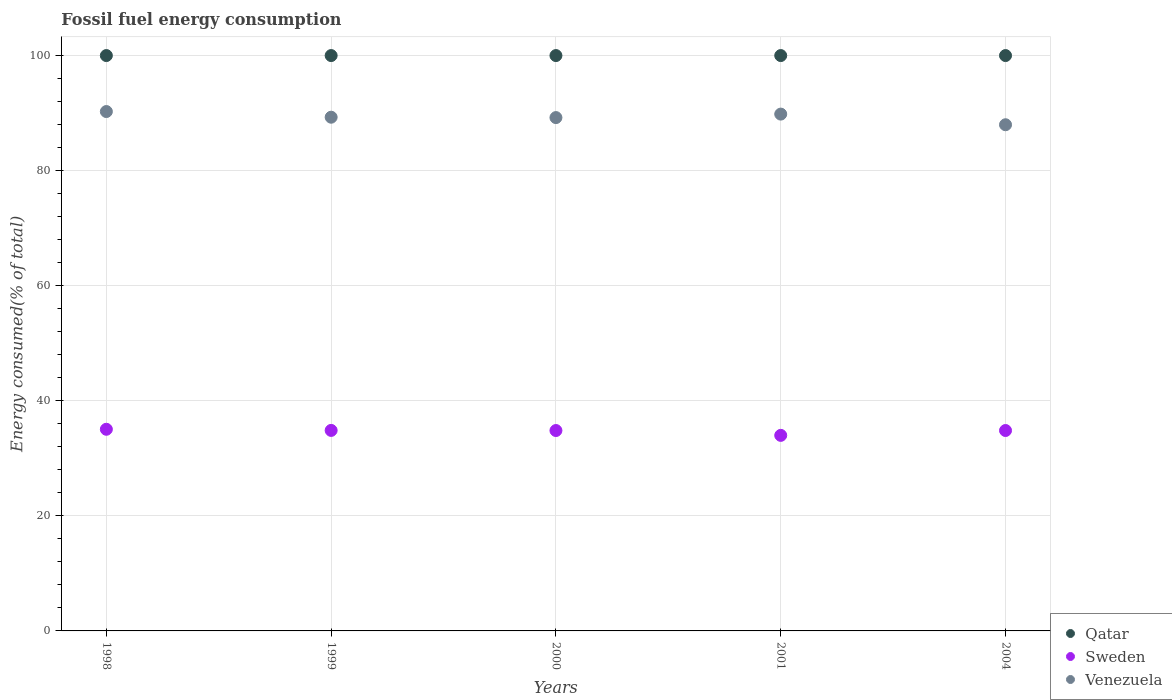How many different coloured dotlines are there?
Keep it short and to the point. 3. What is the percentage of energy consumed in Sweden in 2004?
Your answer should be compact. 34.83. Across all years, what is the maximum percentage of energy consumed in Sweden?
Give a very brief answer. 35.05. Across all years, what is the minimum percentage of energy consumed in Venezuela?
Ensure brevity in your answer.  87.98. In which year was the percentage of energy consumed in Qatar minimum?
Offer a terse response. 2000. What is the total percentage of energy consumed in Venezuela in the graph?
Your answer should be compact. 446.58. What is the difference between the percentage of energy consumed in Sweden in 1999 and that in 2000?
Your answer should be very brief. 0.02. What is the difference between the percentage of energy consumed in Sweden in 1998 and the percentage of energy consumed in Venezuela in 1999?
Your answer should be very brief. -54.24. What is the average percentage of energy consumed in Sweden per year?
Ensure brevity in your answer.  34.71. In the year 2004, what is the difference between the percentage of energy consumed in Qatar and percentage of energy consumed in Venezuela?
Offer a terse response. 12.02. What is the ratio of the percentage of energy consumed in Sweden in 2001 to that in 2004?
Offer a terse response. 0.98. Is the percentage of energy consumed in Qatar in 1998 less than that in 1999?
Give a very brief answer. No. What is the difference between the highest and the lowest percentage of energy consumed in Qatar?
Make the answer very short. 9.157250900670988e-6. In how many years, is the percentage of energy consumed in Venezuela greater than the average percentage of energy consumed in Venezuela taken over all years?
Keep it short and to the point. 2. Is the sum of the percentage of energy consumed in Qatar in 1998 and 2000 greater than the maximum percentage of energy consumed in Sweden across all years?
Give a very brief answer. Yes. How many dotlines are there?
Provide a succinct answer. 3. How many years are there in the graph?
Provide a short and direct response. 5. Are the values on the major ticks of Y-axis written in scientific E-notation?
Offer a very short reply. No. Where does the legend appear in the graph?
Your answer should be compact. Bottom right. How many legend labels are there?
Offer a terse response. 3. How are the legend labels stacked?
Provide a succinct answer. Vertical. What is the title of the graph?
Give a very brief answer. Fossil fuel energy consumption. What is the label or title of the Y-axis?
Your answer should be compact. Energy consumed(% of total). What is the Energy consumed(% of total) of Sweden in 1998?
Your answer should be compact. 35.05. What is the Energy consumed(% of total) of Venezuela in 1998?
Give a very brief answer. 90.27. What is the Energy consumed(% of total) in Qatar in 1999?
Your answer should be compact. 100. What is the Energy consumed(% of total) of Sweden in 1999?
Offer a terse response. 34.85. What is the Energy consumed(% of total) in Venezuela in 1999?
Your answer should be compact. 89.29. What is the Energy consumed(% of total) of Qatar in 2000?
Offer a terse response. 100. What is the Energy consumed(% of total) in Sweden in 2000?
Offer a very short reply. 34.83. What is the Energy consumed(% of total) of Venezuela in 2000?
Your answer should be compact. 89.22. What is the Energy consumed(% of total) in Qatar in 2001?
Your answer should be compact. 100. What is the Energy consumed(% of total) in Sweden in 2001?
Your answer should be compact. 33.99. What is the Energy consumed(% of total) of Venezuela in 2001?
Provide a short and direct response. 89.83. What is the Energy consumed(% of total) in Sweden in 2004?
Provide a short and direct response. 34.83. What is the Energy consumed(% of total) of Venezuela in 2004?
Ensure brevity in your answer.  87.98. Across all years, what is the maximum Energy consumed(% of total) of Sweden?
Your answer should be compact. 35.05. Across all years, what is the maximum Energy consumed(% of total) in Venezuela?
Offer a terse response. 90.27. Across all years, what is the minimum Energy consumed(% of total) of Qatar?
Provide a short and direct response. 100. Across all years, what is the minimum Energy consumed(% of total) of Sweden?
Your answer should be very brief. 33.99. Across all years, what is the minimum Energy consumed(% of total) of Venezuela?
Your answer should be very brief. 87.98. What is the total Energy consumed(% of total) of Qatar in the graph?
Your answer should be very brief. 500. What is the total Energy consumed(% of total) in Sweden in the graph?
Provide a succinct answer. 173.55. What is the total Energy consumed(% of total) of Venezuela in the graph?
Keep it short and to the point. 446.58. What is the difference between the Energy consumed(% of total) in Qatar in 1998 and that in 1999?
Give a very brief answer. 0. What is the difference between the Energy consumed(% of total) of Sweden in 1998 and that in 1999?
Offer a terse response. 0.2. What is the difference between the Energy consumed(% of total) in Venezuela in 1998 and that in 1999?
Make the answer very short. 0.98. What is the difference between the Energy consumed(% of total) in Qatar in 1998 and that in 2000?
Make the answer very short. 0. What is the difference between the Energy consumed(% of total) in Sweden in 1998 and that in 2000?
Offer a very short reply. 0.22. What is the difference between the Energy consumed(% of total) in Venezuela in 1998 and that in 2000?
Provide a succinct answer. 1.05. What is the difference between the Energy consumed(% of total) in Qatar in 1998 and that in 2001?
Ensure brevity in your answer.  0. What is the difference between the Energy consumed(% of total) in Sweden in 1998 and that in 2001?
Your answer should be compact. 1.06. What is the difference between the Energy consumed(% of total) in Venezuela in 1998 and that in 2001?
Give a very brief answer. 0.44. What is the difference between the Energy consumed(% of total) of Sweden in 1998 and that in 2004?
Provide a succinct answer. 0.22. What is the difference between the Energy consumed(% of total) in Venezuela in 1998 and that in 2004?
Offer a terse response. 2.29. What is the difference between the Energy consumed(% of total) of Sweden in 1999 and that in 2000?
Your answer should be compact. 0.02. What is the difference between the Energy consumed(% of total) of Venezuela in 1999 and that in 2000?
Provide a short and direct response. 0.07. What is the difference between the Energy consumed(% of total) of Qatar in 1999 and that in 2001?
Give a very brief answer. -0. What is the difference between the Energy consumed(% of total) of Sweden in 1999 and that in 2001?
Ensure brevity in your answer.  0.86. What is the difference between the Energy consumed(% of total) in Venezuela in 1999 and that in 2001?
Keep it short and to the point. -0.54. What is the difference between the Energy consumed(% of total) in Sweden in 1999 and that in 2004?
Your answer should be compact. 0.02. What is the difference between the Energy consumed(% of total) in Venezuela in 1999 and that in 2004?
Keep it short and to the point. 1.31. What is the difference between the Energy consumed(% of total) in Sweden in 2000 and that in 2001?
Ensure brevity in your answer.  0.84. What is the difference between the Energy consumed(% of total) of Venezuela in 2000 and that in 2001?
Provide a short and direct response. -0.61. What is the difference between the Energy consumed(% of total) in Sweden in 2000 and that in 2004?
Make the answer very short. -0. What is the difference between the Energy consumed(% of total) of Venezuela in 2000 and that in 2004?
Ensure brevity in your answer.  1.24. What is the difference between the Energy consumed(% of total) of Sweden in 2001 and that in 2004?
Provide a short and direct response. -0.84. What is the difference between the Energy consumed(% of total) of Venezuela in 2001 and that in 2004?
Your response must be concise. 1.85. What is the difference between the Energy consumed(% of total) in Qatar in 1998 and the Energy consumed(% of total) in Sweden in 1999?
Your answer should be very brief. 65.15. What is the difference between the Energy consumed(% of total) of Qatar in 1998 and the Energy consumed(% of total) of Venezuela in 1999?
Provide a short and direct response. 10.71. What is the difference between the Energy consumed(% of total) of Sweden in 1998 and the Energy consumed(% of total) of Venezuela in 1999?
Keep it short and to the point. -54.24. What is the difference between the Energy consumed(% of total) in Qatar in 1998 and the Energy consumed(% of total) in Sweden in 2000?
Offer a very short reply. 65.17. What is the difference between the Energy consumed(% of total) of Qatar in 1998 and the Energy consumed(% of total) of Venezuela in 2000?
Ensure brevity in your answer.  10.78. What is the difference between the Energy consumed(% of total) of Sweden in 1998 and the Energy consumed(% of total) of Venezuela in 2000?
Offer a very short reply. -54.17. What is the difference between the Energy consumed(% of total) of Qatar in 1998 and the Energy consumed(% of total) of Sweden in 2001?
Your answer should be very brief. 66.01. What is the difference between the Energy consumed(% of total) in Qatar in 1998 and the Energy consumed(% of total) in Venezuela in 2001?
Keep it short and to the point. 10.17. What is the difference between the Energy consumed(% of total) in Sweden in 1998 and the Energy consumed(% of total) in Venezuela in 2001?
Make the answer very short. -54.78. What is the difference between the Energy consumed(% of total) in Qatar in 1998 and the Energy consumed(% of total) in Sweden in 2004?
Offer a terse response. 65.17. What is the difference between the Energy consumed(% of total) of Qatar in 1998 and the Energy consumed(% of total) of Venezuela in 2004?
Offer a very short reply. 12.02. What is the difference between the Energy consumed(% of total) in Sweden in 1998 and the Energy consumed(% of total) in Venezuela in 2004?
Offer a terse response. -52.93. What is the difference between the Energy consumed(% of total) in Qatar in 1999 and the Energy consumed(% of total) in Sweden in 2000?
Offer a terse response. 65.17. What is the difference between the Energy consumed(% of total) of Qatar in 1999 and the Energy consumed(% of total) of Venezuela in 2000?
Make the answer very short. 10.78. What is the difference between the Energy consumed(% of total) in Sweden in 1999 and the Energy consumed(% of total) in Venezuela in 2000?
Provide a succinct answer. -54.37. What is the difference between the Energy consumed(% of total) of Qatar in 1999 and the Energy consumed(% of total) of Sweden in 2001?
Keep it short and to the point. 66.01. What is the difference between the Energy consumed(% of total) in Qatar in 1999 and the Energy consumed(% of total) in Venezuela in 2001?
Offer a terse response. 10.17. What is the difference between the Energy consumed(% of total) of Sweden in 1999 and the Energy consumed(% of total) of Venezuela in 2001?
Keep it short and to the point. -54.98. What is the difference between the Energy consumed(% of total) of Qatar in 1999 and the Energy consumed(% of total) of Sweden in 2004?
Provide a succinct answer. 65.17. What is the difference between the Energy consumed(% of total) of Qatar in 1999 and the Energy consumed(% of total) of Venezuela in 2004?
Offer a very short reply. 12.02. What is the difference between the Energy consumed(% of total) in Sweden in 1999 and the Energy consumed(% of total) in Venezuela in 2004?
Offer a very short reply. -53.13. What is the difference between the Energy consumed(% of total) in Qatar in 2000 and the Energy consumed(% of total) in Sweden in 2001?
Ensure brevity in your answer.  66.01. What is the difference between the Energy consumed(% of total) in Qatar in 2000 and the Energy consumed(% of total) in Venezuela in 2001?
Make the answer very short. 10.17. What is the difference between the Energy consumed(% of total) of Sweden in 2000 and the Energy consumed(% of total) of Venezuela in 2001?
Ensure brevity in your answer.  -55. What is the difference between the Energy consumed(% of total) in Qatar in 2000 and the Energy consumed(% of total) in Sweden in 2004?
Ensure brevity in your answer.  65.17. What is the difference between the Energy consumed(% of total) of Qatar in 2000 and the Energy consumed(% of total) of Venezuela in 2004?
Make the answer very short. 12.02. What is the difference between the Energy consumed(% of total) of Sweden in 2000 and the Energy consumed(% of total) of Venezuela in 2004?
Your answer should be very brief. -53.15. What is the difference between the Energy consumed(% of total) of Qatar in 2001 and the Energy consumed(% of total) of Sweden in 2004?
Offer a terse response. 65.17. What is the difference between the Energy consumed(% of total) of Qatar in 2001 and the Energy consumed(% of total) of Venezuela in 2004?
Provide a short and direct response. 12.02. What is the difference between the Energy consumed(% of total) of Sweden in 2001 and the Energy consumed(% of total) of Venezuela in 2004?
Your answer should be compact. -53.99. What is the average Energy consumed(% of total) of Qatar per year?
Provide a short and direct response. 100. What is the average Energy consumed(% of total) of Sweden per year?
Your answer should be compact. 34.71. What is the average Energy consumed(% of total) in Venezuela per year?
Offer a very short reply. 89.32. In the year 1998, what is the difference between the Energy consumed(% of total) of Qatar and Energy consumed(% of total) of Sweden?
Your response must be concise. 64.95. In the year 1998, what is the difference between the Energy consumed(% of total) in Qatar and Energy consumed(% of total) in Venezuela?
Offer a very short reply. 9.73. In the year 1998, what is the difference between the Energy consumed(% of total) in Sweden and Energy consumed(% of total) in Venezuela?
Offer a very short reply. -55.22. In the year 1999, what is the difference between the Energy consumed(% of total) of Qatar and Energy consumed(% of total) of Sweden?
Give a very brief answer. 65.15. In the year 1999, what is the difference between the Energy consumed(% of total) in Qatar and Energy consumed(% of total) in Venezuela?
Provide a short and direct response. 10.71. In the year 1999, what is the difference between the Energy consumed(% of total) of Sweden and Energy consumed(% of total) of Venezuela?
Offer a terse response. -54.44. In the year 2000, what is the difference between the Energy consumed(% of total) of Qatar and Energy consumed(% of total) of Sweden?
Your answer should be very brief. 65.17. In the year 2000, what is the difference between the Energy consumed(% of total) of Qatar and Energy consumed(% of total) of Venezuela?
Keep it short and to the point. 10.78. In the year 2000, what is the difference between the Energy consumed(% of total) in Sweden and Energy consumed(% of total) in Venezuela?
Provide a succinct answer. -54.39. In the year 2001, what is the difference between the Energy consumed(% of total) of Qatar and Energy consumed(% of total) of Sweden?
Provide a succinct answer. 66.01. In the year 2001, what is the difference between the Energy consumed(% of total) in Qatar and Energy consumed(% of total) in Venezuela?
Keep it short and to the point. 10.17. In the year 2001, what is the difference between the Energy consumed(% of total) in Sweden and Energy consumed(% of total) in Venezuela?
Keep it short and to the point. -55.84. In the year 2004, what is the difference between the Energy consumed(% of total) in Qatar and Energy consumed(% of total) in Sweden?
Give a very brief answer. 65.17. In the year 2004, what is the difference between the Energy consumed(% of total) of Qatar and Energy consumed(% of total) of Venezuela?
Make the answer very short. 12.02. In the year 2004, what is the difference between the Energy consumed(% of total) of Sweden and Energy consumed(% of total) of Venezuela?
Provide a succinct answer. -53.14. What is the ratio of the Energy consumed(% of total) of Sweden in 1998 to that in 1999?
Your answer should be very brief. 1.01. What is the ratio of the Energy consumed(% of total) of Venezuela in 1998 to that in 1999?
Ensure brevity in your answer.  1.01. What is the ratio of the Energy consumed(% of total) in Qatar in 1998 to that in 2000?
Make the answer very short. 1. What is the ratio of the Energy consumed(% of total) in Sweden in 1998 to that in 2000?
Make the answer very short. 1.01. What is the ratio of the Energy consumed(% of total) of Venezuela in 1998 to that in 2000?
Keep it short and to the point. 1.01. What is the ratio of the Energy consumed(% of total) in Qatar in 1998 to that in 2001?
Your response must be concise. 1. What is the ratio of the Energy consumed(% of total) in Sweden in 1998 to that in 2001?
Make the answer very short. 1.03. What is the ratio of the Energy consumed(% of total) in Qatar in 1998 to that in 2004?
Your answer should be very brief. 1. What is the ratio of the Energy consumed(% of total) in Sweden in 1998 to that in 2004?
Your answer should be very brief. 1.01. What is the ratio of the Energy consumed(% of total) of Venezuela in 1998 to that in 2004?
Offer a very short reply. 1.03. What is the ratio of the Energy consumed(% of total) of Qatar in 1999 to that in 2000?
Your answer should be very brief. 1. What is the ratio of the Energy consumed(% of total) of Sweden in 1999 to that in 2001?
Provide a succinct answer. 1.03. What is the ratio of the Energy consumed(% of total) of Venezuela in 1999 to that in 2001?
Your response must be concise. 0.99. What is the ratio of the Energy consumed(% of total) in Qatar in 1999 to that in 2004?
Offer a very short reply. 1. What is the ratio of the Energy consumed(% of total) in Sweden in 1999 to that in 2004?
Your answer should be compact. 1. What is the ratio of the Energy consumed(% of total) of Venezuela in 1999 to that in 2004?
Keep it short and to the point. 1.01. What is the ratio of the Energy consumed(% of total) of Qatar in 2000 to that in 2001?
Ensure brevity in your answer.  1. What is the ratio of the Energy consumed(% of total) in Sweden in 2000 to that in 2001?
Your answer should be very brief. 1.02. What is the ratio of the Energy consumed(% of total) of Venezuela in 2000 to that in 2004?
Keep it short and to the point. 1.01. What is the ratio of the Energy consumed(% of total) in Qatar in 2001 to that in 2004?
Make the answer very short. 1. What is the ratio of the Energy consumed(% of total) in Sweden in 2001 to that in 2004?
Keep it short and to the point. 0.98. What is the ratio of the Energy consumed(% of total) of Venezuela in 2001 to that in 2004?
Give a very brief answer. 1.02. What is the difference between the highest and the second highest Energy consumed(% of total) of Qatar?
Your answer should be very brief. 0. What is the difference between the highest and the second highest Energy consumed(% of total) in Sweden?
Give a very brief answer. 0.2. What is the difference between the highest and the second highest Energy consumed(% of total) of Venezuela?
Provide a short and direct response. 0.44. What is the difference between the highest and the lowest Energy consumed(% of total) of Sweden?
Your response must be concise. 1.06. What is the difference between the highest and the lowest Energy consumed(% of total) in Venezuela?
Your answer should be compact. 2.29. 